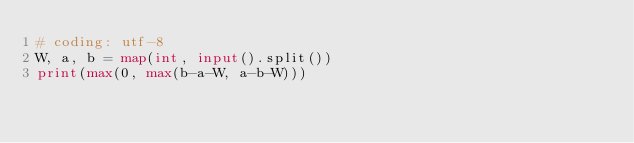<code> <loc_0><loc_0><loc_500><loc_500><_Python_># coding: utf-8
W, a, b = map(int, input().split())
print(max(0, max(b-a-W, a-b-W)))</code> 